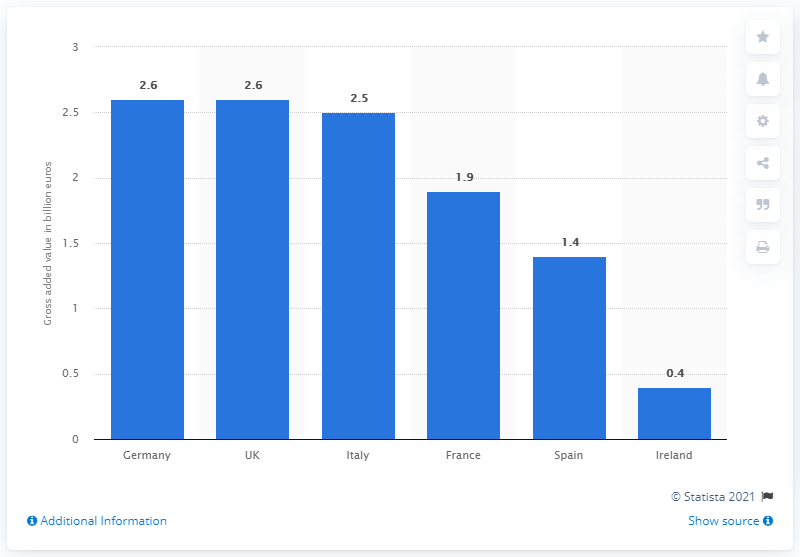Mention a couple of crucial points in this snapshot. The total economic impact of Facebook's broad and narrow effects in Germany was estimated to be 2.6 billion euros. 